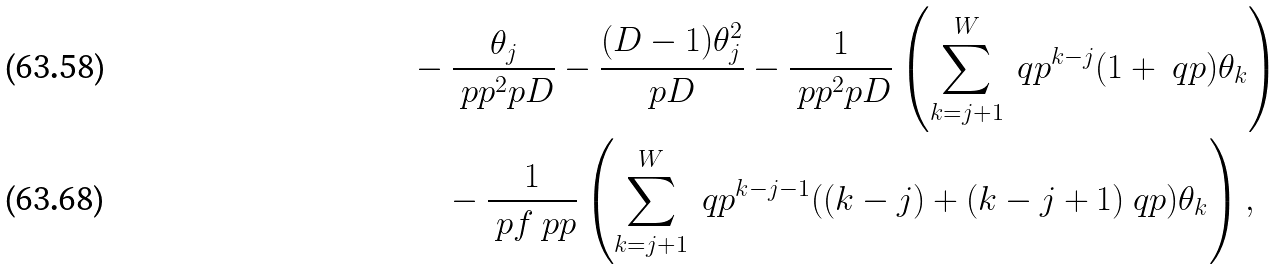<formula> <loc_0><loc_0><loc_500><loc_500>& - \frac { \theta _ { j } } { \ p p ^ { 2 } p D } - \frac { ( D - 1 ) \theta _ { j } ^ { 2 } } { p D } - \frac { 1 } { \ p p ^ { 2 } p D } \left ( \sum ^ { W } _ { k = j + 1 } \ q p ^ { k - j } ( 1 + \ q p ) \theta _ { k } \right ) \\ & \quad - \frac { 1 } { \ p f \ p p } \left ( \sum ^ { W } _ { k = j + 1 } \ q p ^ { k - j - 1 } ( ( k - j ) + ( k - j + 1 ) \ q p ) \theta _ { k } \right ) ,</formula> 